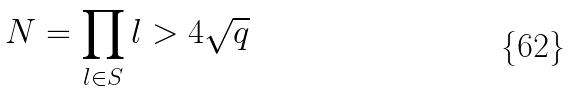Convert formula to latex. <formula><loc_0><loc_0><loc_500><loc_500>N = \prod _ { l \in S } l > 4 \sqrt { q }</formula> 